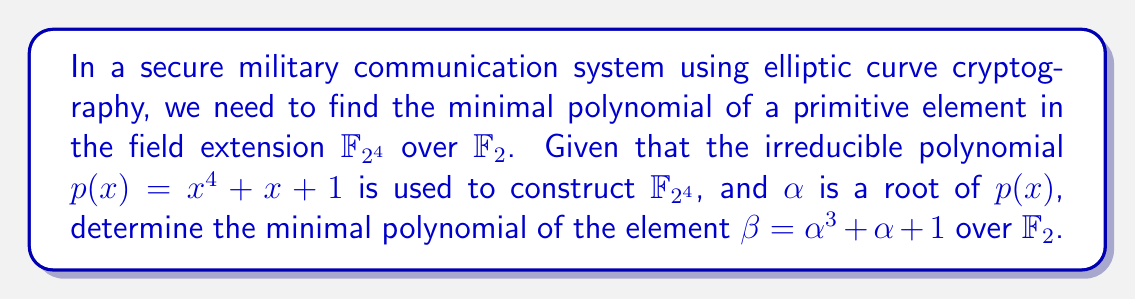Teach me how to tackle this problem. 1) First, we need to express $\beta$ in terms of powers of $\alpha$:
   $\beta = \alpha^3 + \alpha + 1$

2) Now, we need to find the powers of $\beta$ modulo $p(x)$:
   $\beta^2 = (\alpha^3 + \alpha + 1)^2 = \alpha^6 + \alpha^2 + 1$
   $\alpha^6 = \alpha^2(\alpha^4) = \alpha^2(\alpha + 1) = \alpha^3 + \alpha^2$
   So, $\beta^2 = \alpha^3 + \alpha^2 + \alpha^2 + 1 = \alpha^3 + 1$

3) $\beta^4 = (\beta^2)^2 = (\alpha^3 + 1)^2 = \alpha^6 + 1 = \alpha^3 + \alpha^2 + 1$

4) $\beta^8 = (\beta^4)^2 = (\alpha^3 + \alpha^2 + 1)^2 = \alpha^6 + \alpha^4 + 1 = \alpha^3 + \alpha^2 + \alpha + 1$

5) $\beta^{16} = (\beta^8)^2 = (\alpha^3 + \alpha^2 + \alpha + 1)^2 = \alpha^6 + \alpha^4 + \alpha^2 + 1 = \alpha^3 + \alpha^2 + \alpha^2 + \alpha + 1 = \alpha^3 + \alpha + 1 = \beta$

6) Since $\beta^{16} = \beta$, the minimal polynomial of $\beta$ over $\mathbb{F}_2$ is $x^{15} + 1$.

This is because $\beta$ is a root of $x^{15} + 1$, and this is the smallest degree polynomial with coefficients in $\mathbb{F}_2$ that has $\beta$ as a root.
Answer: $x^{15} + 1$ 